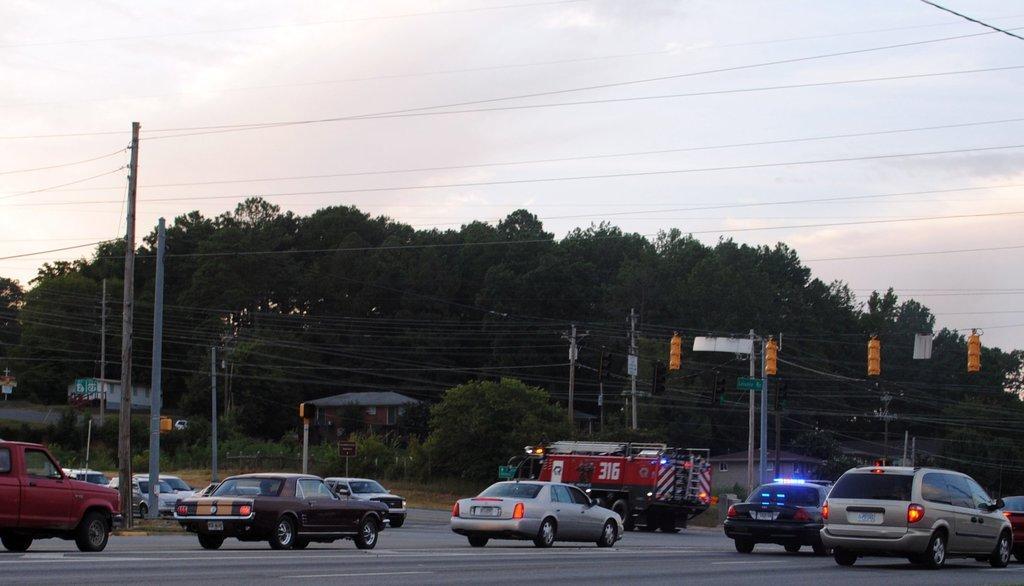Please provide a concise description of this image. This image consists of a road. On which there are many cars. In the front, we can see a truck. In the background, there are many trees. In the middle, we can see many poles along with wires. At the top, there are clouds in the sky. 